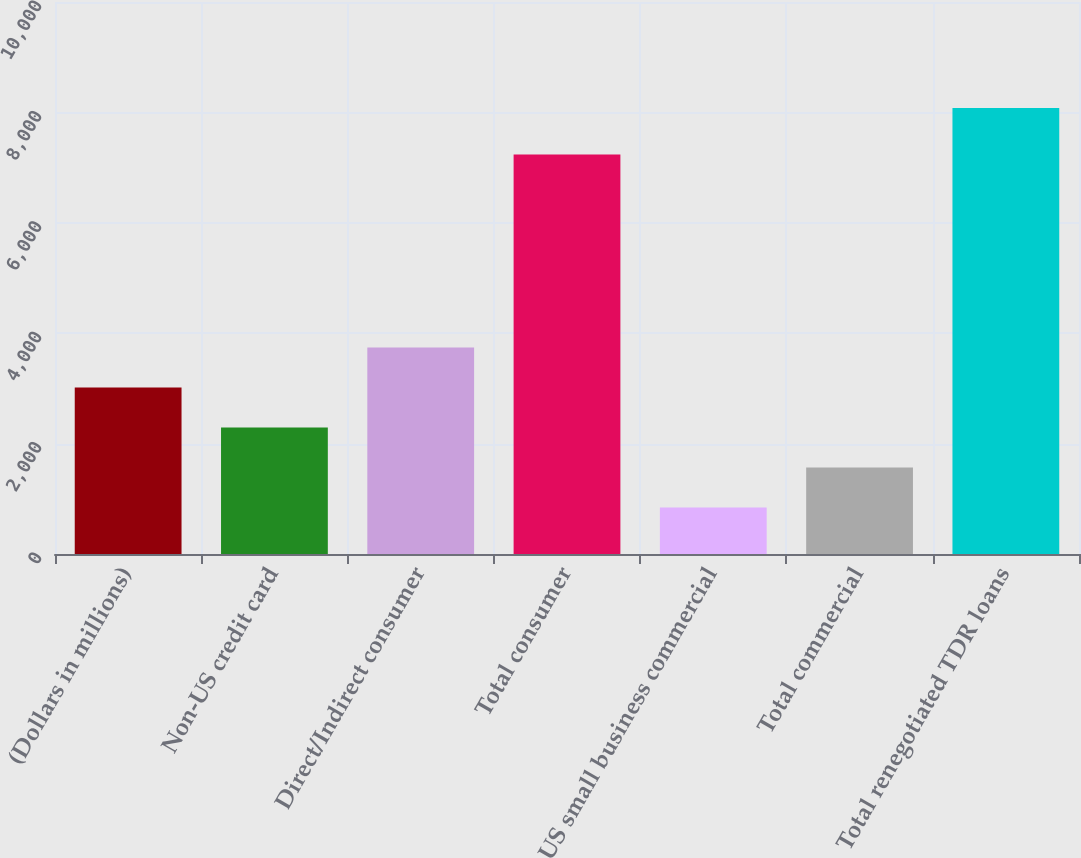<chart> <loc_0><loc_0><loc_500><loc_500><bar_chart><fcel>(Dollars in millions)<fcel>Non-US credit card<fcel>Direct/Indirect consumer<fcel>Total consumer<fcel>US small business commercial<fcel>Total commercial<fcel>Total renegotiated TDR loans<nl><fcel>3015.1<fcel>2291.4<fcel>3738.8<fcel>7237<fcel>844<fcel>1567.7<fcel>8081<nl></chart> 